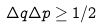<formula> <loc_0><loc_0><loc_500><loc_500>\Delta q \Delta p \geq 1 / 2</formula> 